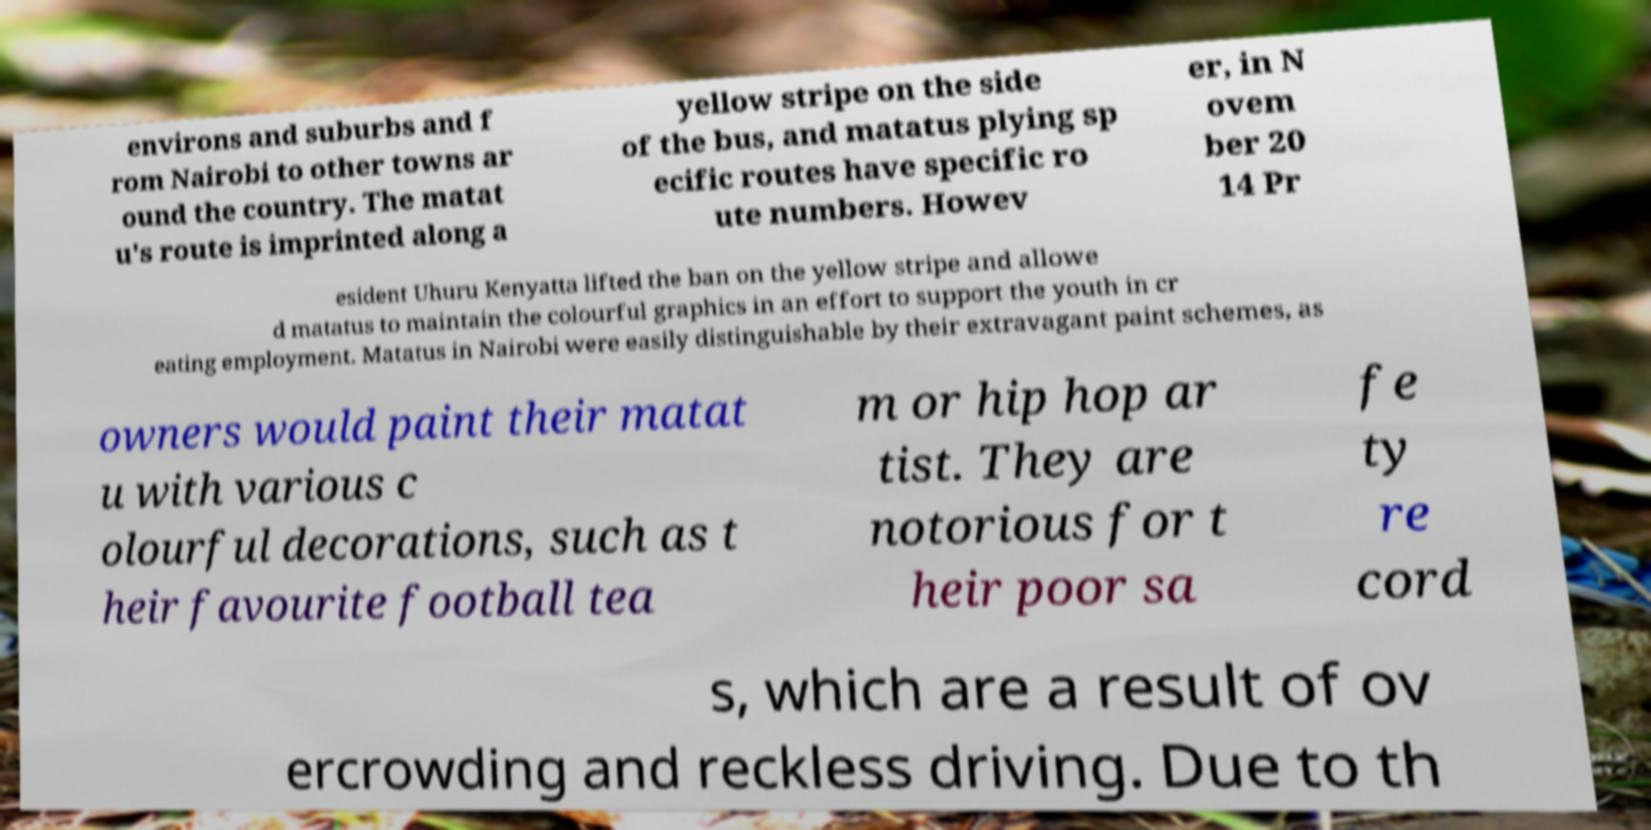Please identify and transcribe the text found in this image. environs and suburbs and f rom Nairobi to other towns ar ound the country. The matat u's route is imprinted along a yellow stripe on the side of the bus, and matatus plying sp ecific routes have specific ro ute numbers. Howev er, in N ovem ber 20 14 Pr esident Uhuru Kenyatta lifted the ban on the yellow stripe and allowe d matatus to maintain the colourful graphics in an effort to support the youth in cr eating employment. Matatus in Nairobi were easily distinguishable by their extravagant paint schemes, as owners would paint their matat u with various c olourful decorations, such as t heir favourite football tea m or hip hop ar tist. They are notorious for t heir poor sa fe ty re cord s, which are a result of ov ercrowding and reckless driving. Due to th 